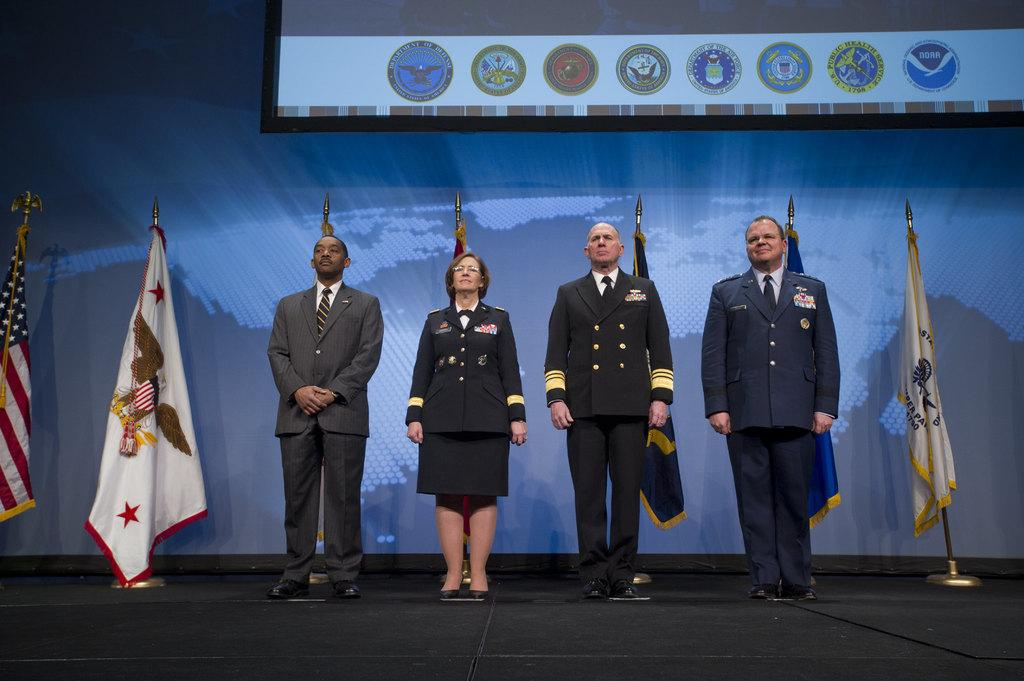How many people are in the image? There are three people in the image. What is the gender of the people in the image? The people in the image are men and women. What are the people wearing? The people are wearing suits. Where are the people standing in the image? The people are standing on a stage. What can be seen behind the people on the stage? There are flags behind the people. What is in front of the people on the stage? There is a screen in front of the people. What type of calculator is being used by the manager in the image? There is no manager or calculator present in the image. 